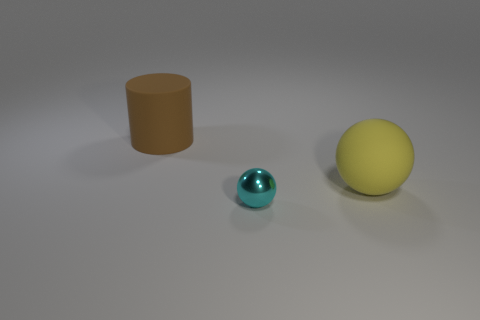Add 3 big brown things. How many objects exist? 6 Subtract all cylinders. How many objects are left? 2 Add 1 large cylinders. How many large cylinders are left? 2 Add 2 shiny objects. How many shiny objects exist? 3 Subtract 0 blue cylinders. How many objects are left? 3 Subtract all small gray rubber cubes. Subtract all balls. How many objects are left? 1 